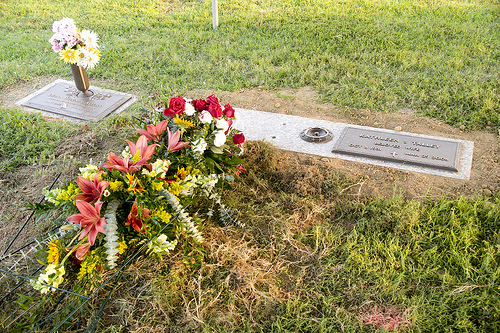<image>
Is the iron pole behind the flowers? Yes. From this viewpoint, the iron pole is positioned behind the flowers, with the flowers partially or fully occluding the iron pole. 